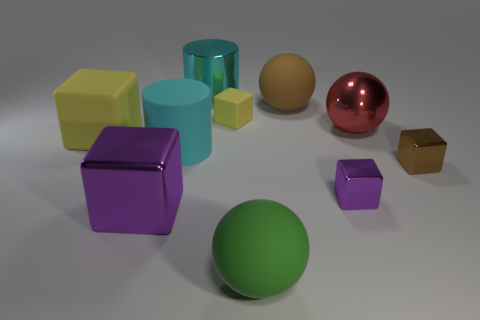Subtract all metal spheres. How many spheres are left? 2 Subtract all red balls. How many yellow cubes are left? 2 Subtract all purple blocks. How many blocks are left? 3 Subtract all cylinders. How many objects are left? 8 Subtract all gray balls. Subtract all green cylinders. How many balls are left? 3 Add 1 big cyan metal objects. How many big cyan metal objects exist? 2 Subtract 0 red cubes. How many objects are left? 10 Subtract all tiny yellow matte objects. Subtract all small brown objects. How many objects are left? 8 Add 4 large green balls. How many large green balls are left? 5 